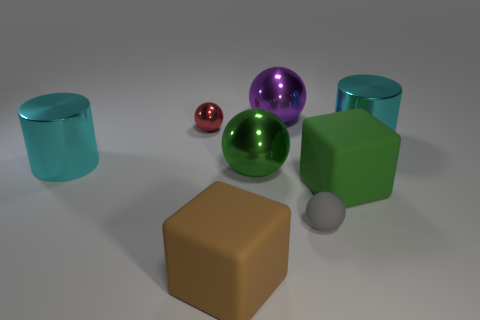How many tiny balls are the same color as the small matte object?
Provide a succinct answer. 0. What material is the tiny object that is in front of the block on the right side of the big green metal sphere made of?
Provide a short and direct response. Rubber. What is the size of the brown block?
Your answer should be very brief. Large. How many gray matte things have the same size as the brown rubber object?
Your answer should be very brief. 0. How many tiny shiny things are the same shape as the brown matte object?
Your response must be concise. 0. Are there an equal number of red metallic spheres right of the large green metallic thing and cyan matte cylinders?
Offer a very short reply. Yes. What shape is the purple object that is the same size as the green ball?
Your response must be concise. Sphere. Are there any other shiny things of the same shape as the red shiny thing?
Ensure brevity in your answer.  Yes. Are there any large objects in front of the cyan metallic thing left of the small object that is on the right side of the purple metal object?
Give a very brief answer. Yes. Are there more large cyan metal cylinders on the left side of the red shiny object than green rubber objects that are left of the green shiny object?
Give a very brief answer. Yes. 